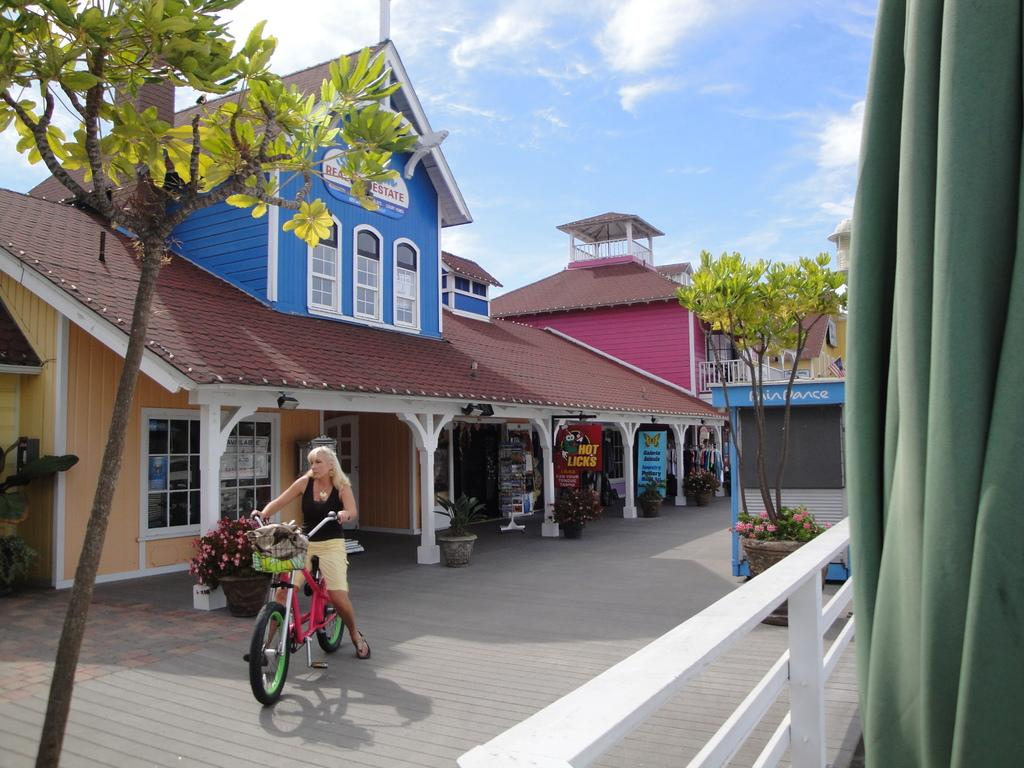What type of surface is the woman riding her cycle on in the image? There is a wooden land in the image, and the woman is riding her cycle on it. What can be seen near the wooden land in the image? There are stores and buildings near the wooden land in the image. What decorative elements are present around the wooden land? Beautiful flower plants and trees are visible around the wooden land. What type of cloth is being used to cover the tray in the image? There is no tray or cloth present in the image. How is the lock being used in the image? There is no lock present in the image. 